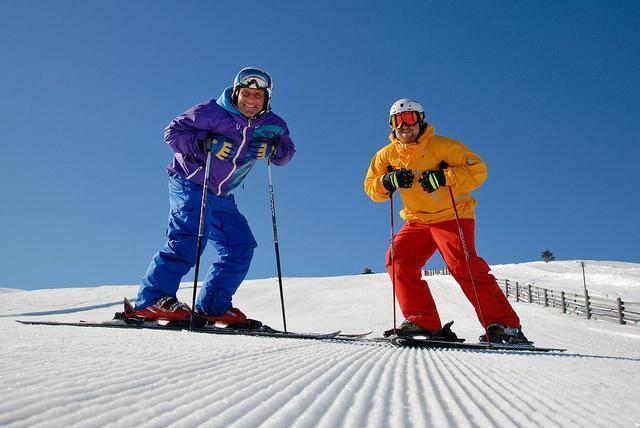How many people can be seen?
Give a very brief answer. 2. How many cats are meowing on a bed?
Give a very brief answer. 0. 